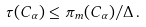Convert formula to latex. <formula><loc_0><loc_0><loc_500><loc_500>\tau ( C _ { \alpha } ) \leq \pi _ { m } ( C _ { \alpha } ) / \Delta \, .</formula> 